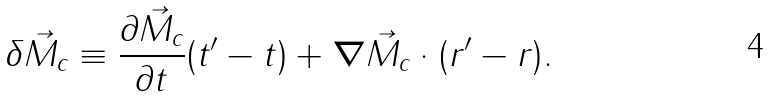Convert formula to latex. <formula><loc_0><loc_0><loc_500><loc_500>\delta \vec { M } _ { c } \equiv \frac { \partial \vec { M } _ { c } } { \partial t } ( t ^ { \prime } - t ) + { \boldsymbol \nabla } \vec { M } _ { c } \cdot ( { r } ^ { \prime } - { r } ) .</formula> 